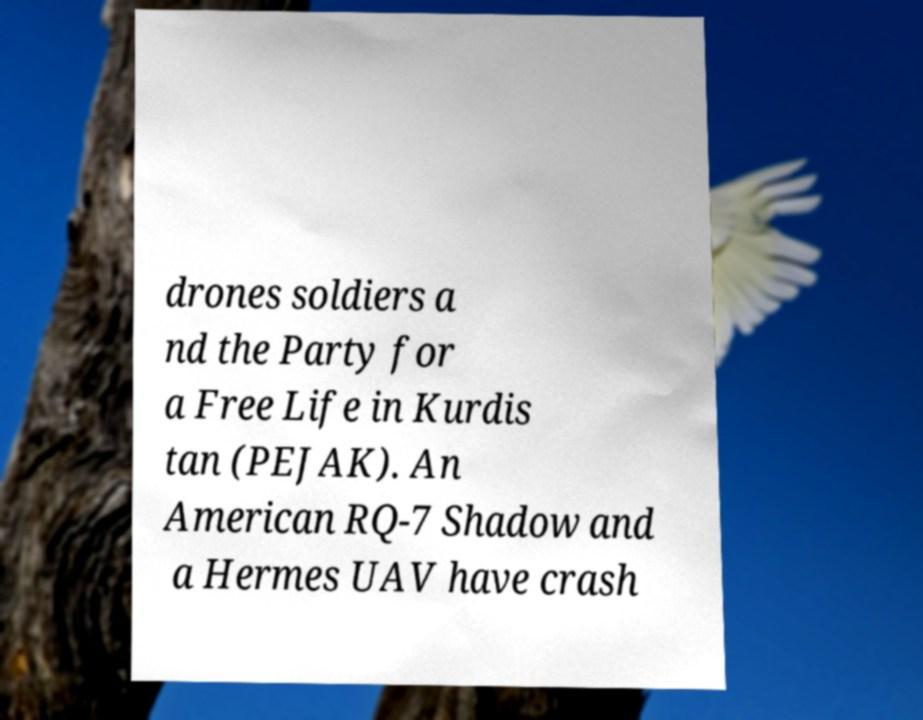What messages or text are displayed in this image? I need them in a readable, typed format. drones soldiers a nd the Party for a Free Life in Kurdis tan (PEJAK). An American RQ-7 Shadow and a Hermes UAV have crash 